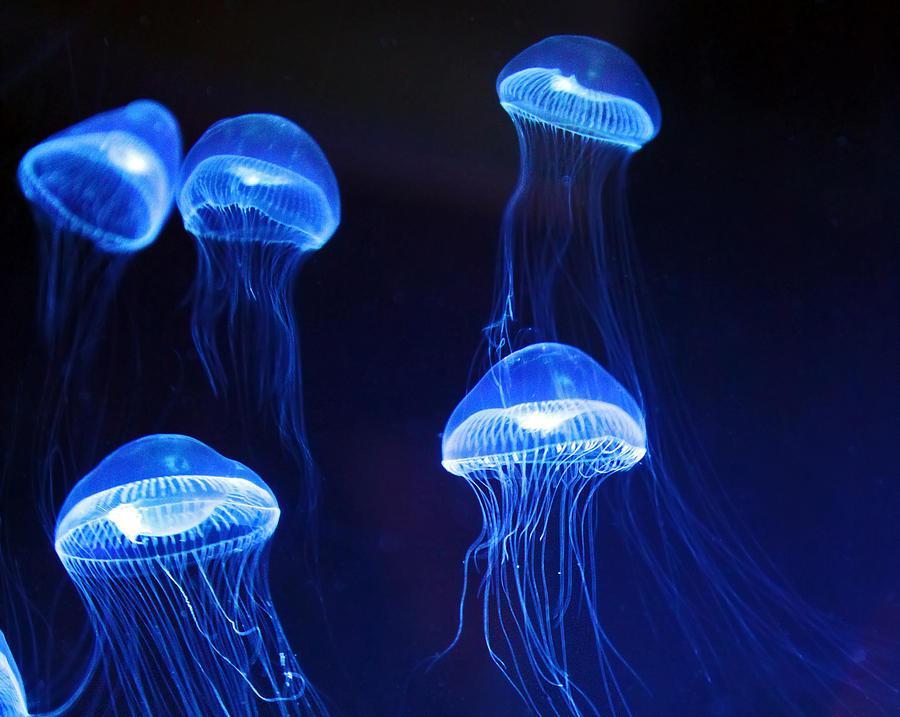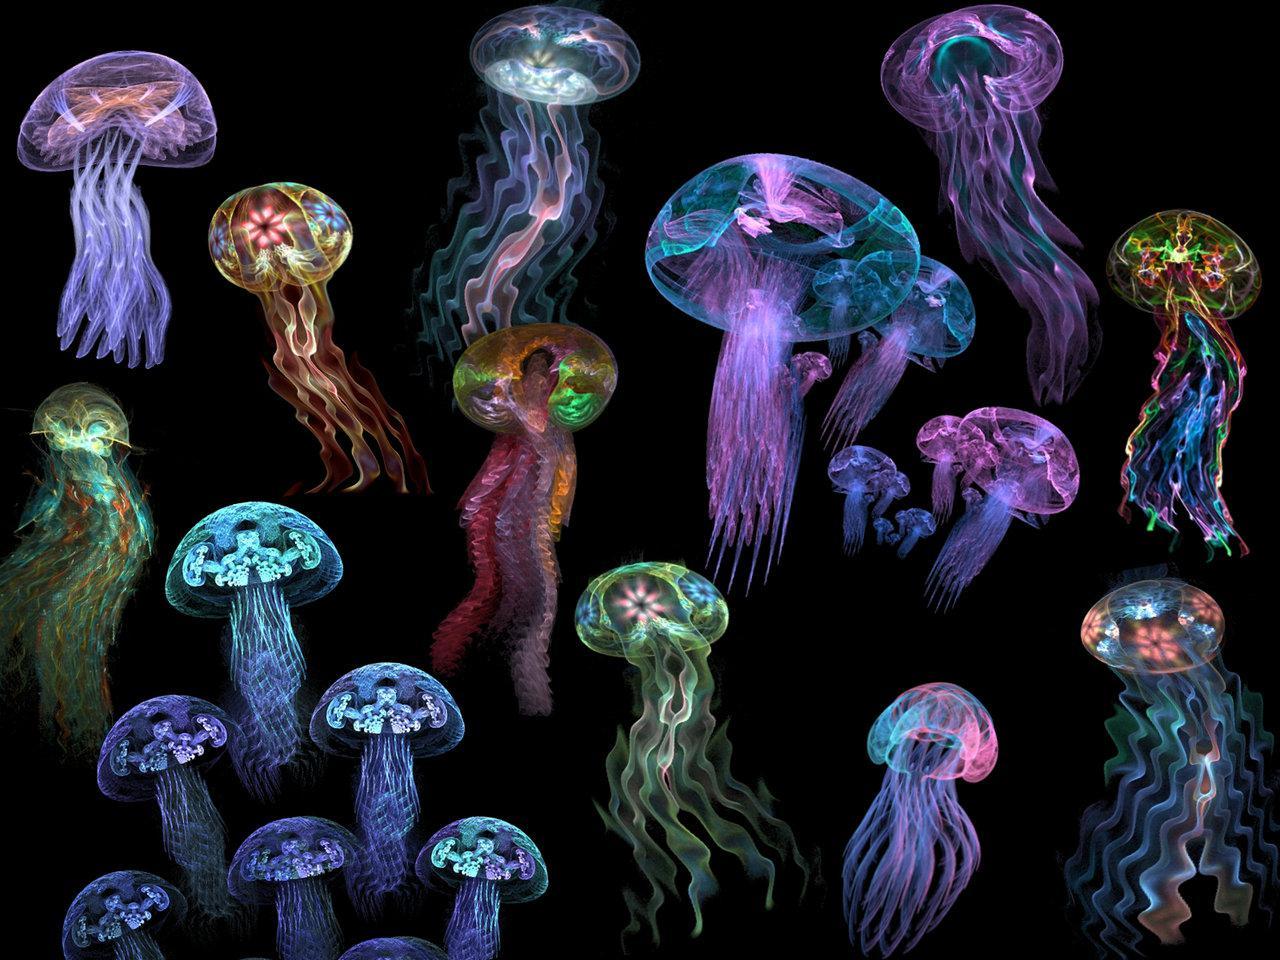The first image is the image on the left, the second image is the image on the right. Considering the images on both sides, is "Left image includes things that look like glowing blue jellyfish." valid? Answer yes or no. Yes. 